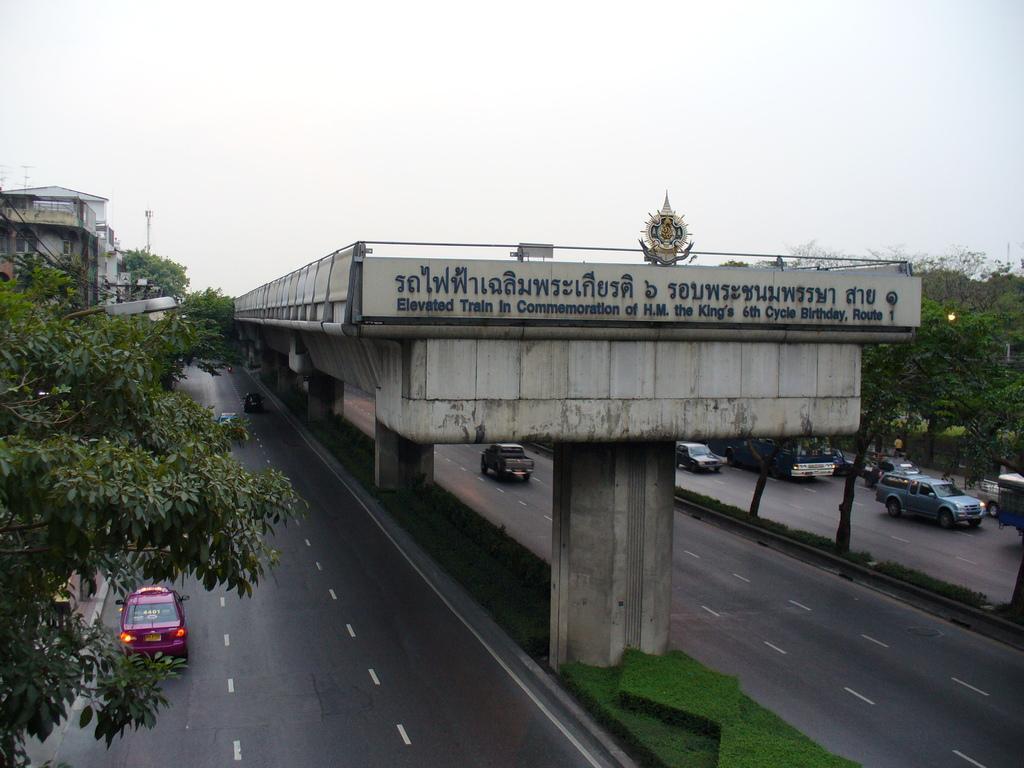In one or two sentences, can you explain what this image depicts? In the image there is a bridge in the middle of the road on the grassland and many cars moving on road on either side of the bridge with trees at the corners and above its sky. 